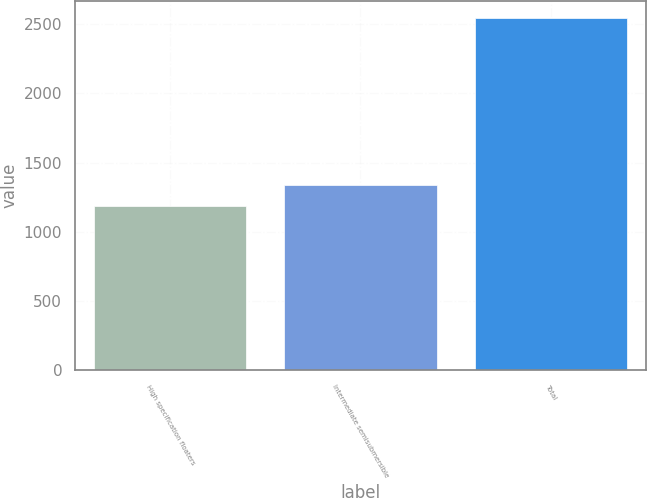Convert chart to OTSL. <chart><loc_0><loc_0><loc_500><loc_500><bar_chart><fcel>High specification floaters<fcel>Intermediate semisubmersible<fcel>Total<nl><fcel>1185<fcel>1340<fcel>2542<nl></chart> 